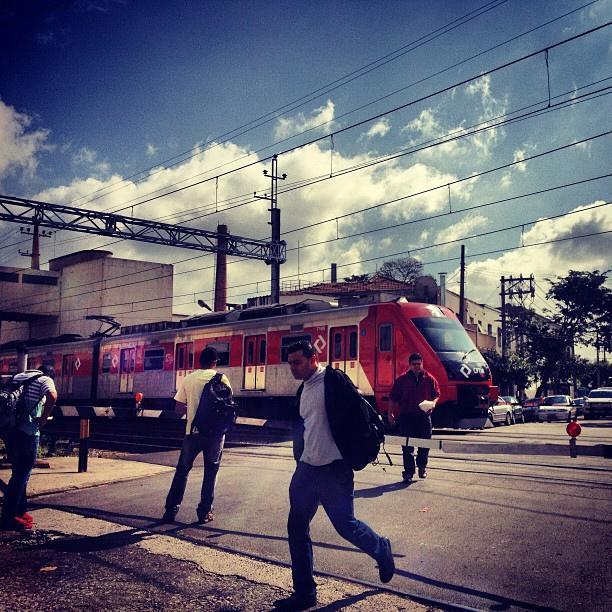How many people are there?
Give a very brief answer. 4. How many women are waiting for the train?
Give a very brief answer. 0. How many planes have orange tail sections?
Give a very brief answer. 0. 